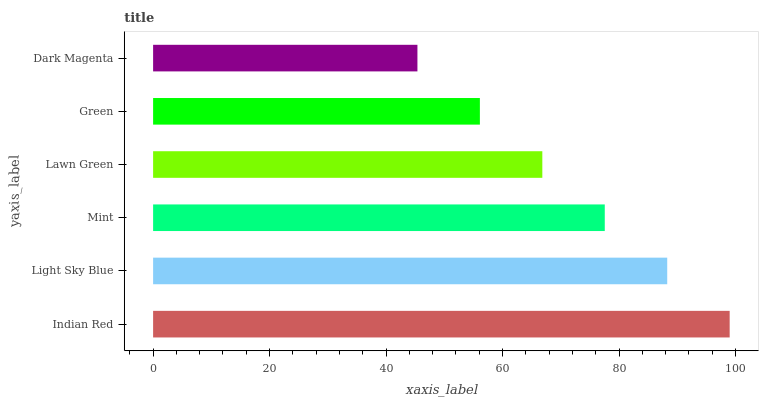Is Dark Magenta the minimum?
Answer yes or no. Yes. Is Indian Red the maximum?
Answer yes or no. Yes. Is Light Sky Blue the minimum?
Answer yes or no. No. Is Light Sky Blue the maximum?
Answer yes or no. No. Is Indian Red greater than Light Sky Blue?
Answer yes or no. Yes. Is Light Sky Blue less than Indian Red?
Answer yes or no. Yes. Is Light Sky Blue greater than Indian Red?
Answer yes or no. No. Is Indian Red less than Light Sky Blue?
Answer yes or no. No. Is Mint the high median?
Answer yes or no. Yes. Is Lawn Green the low median?
Answer yes or no. Yes. Is Indian Red the high median?
Answer yes or no. No. Is Mint the low median?
Answer yes or no. No. 